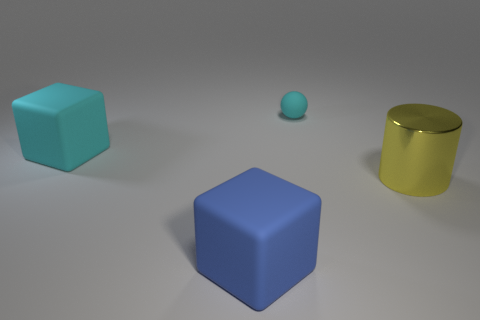Add 3 small purple matte cylinders. How many objects exist? 7 Subtract all spheres. How many objects are left? 3 Subtract 0 gray cylinders. How many objects are left? 4 Subtract all big cyan rubber cubes. Subtract all large purple shiny cylinders. How many objects are left? 3 Add 4 large yellow things. How many large yellow things are left? 5 Add 4 big cylinders. How many big cylinders exist? 5 